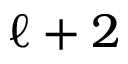<formula> <loc_0><loc_0><loc_500><loc_500>{ \ell + 2 }</formula> 